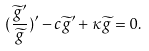Convert formula to latex. <formula><loc_0><loc_0><loc_500><loc_500>( \frac { \widetilde { g } ^ { \prime } } { \widetilde { g } } ) ^ { \prime } - c \widetilde { g } ^ { \prime } + \kappa \widetilde { g } = 0 .</formula> 